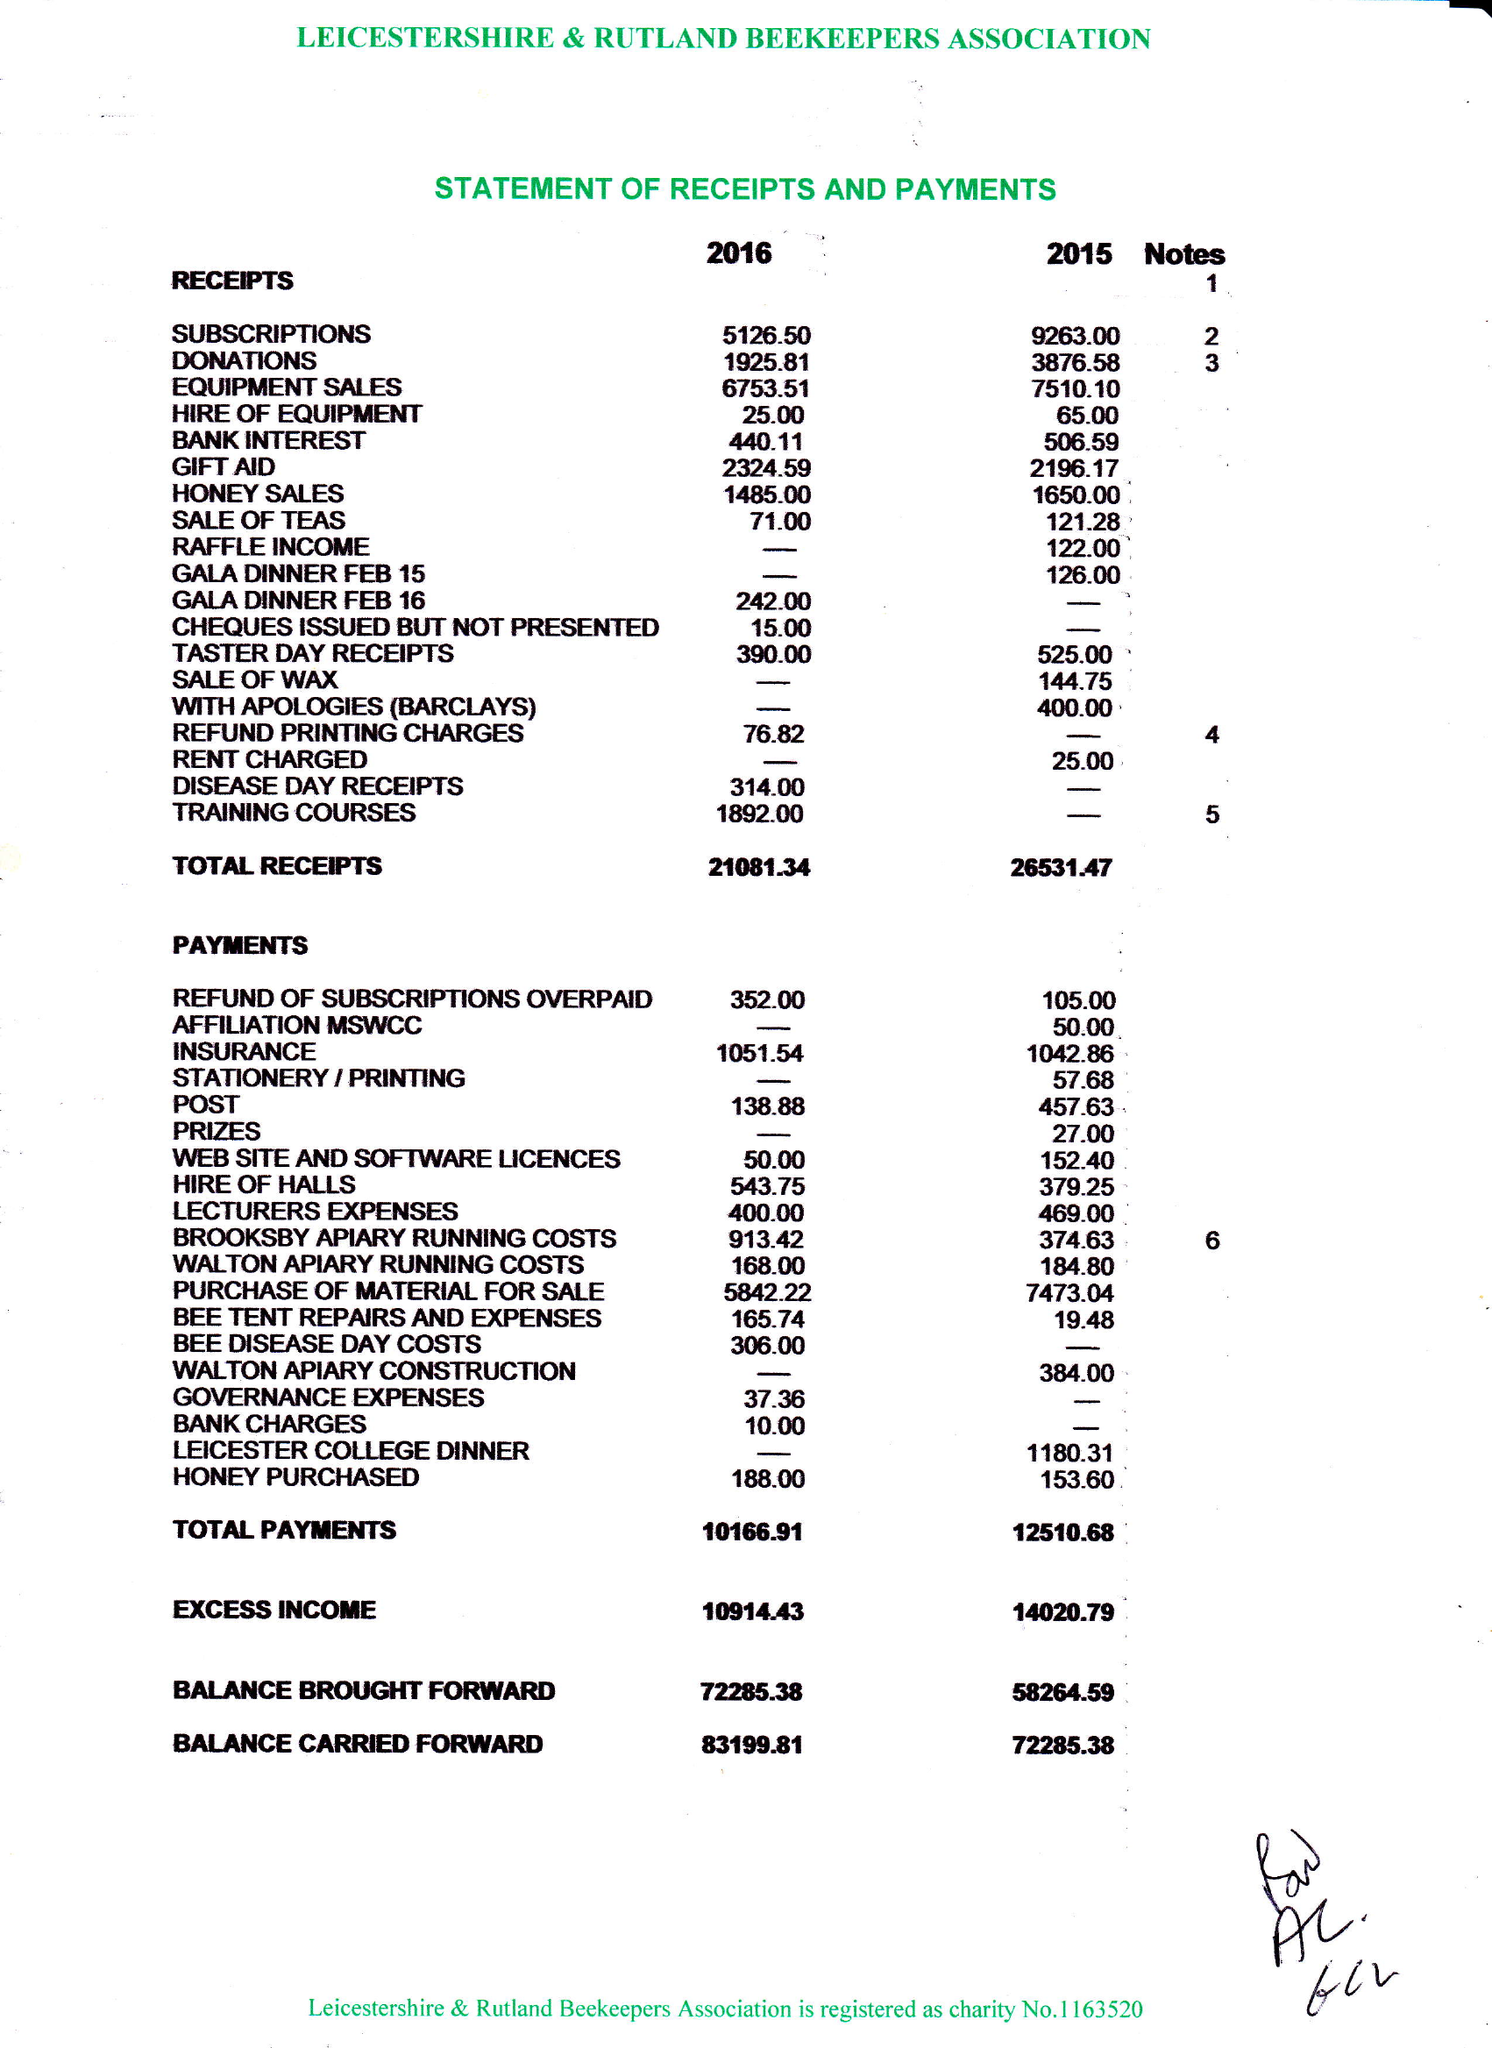What is the value for the address__postcode?
Answer the question using a single word or phrase. LE17 5RQ 